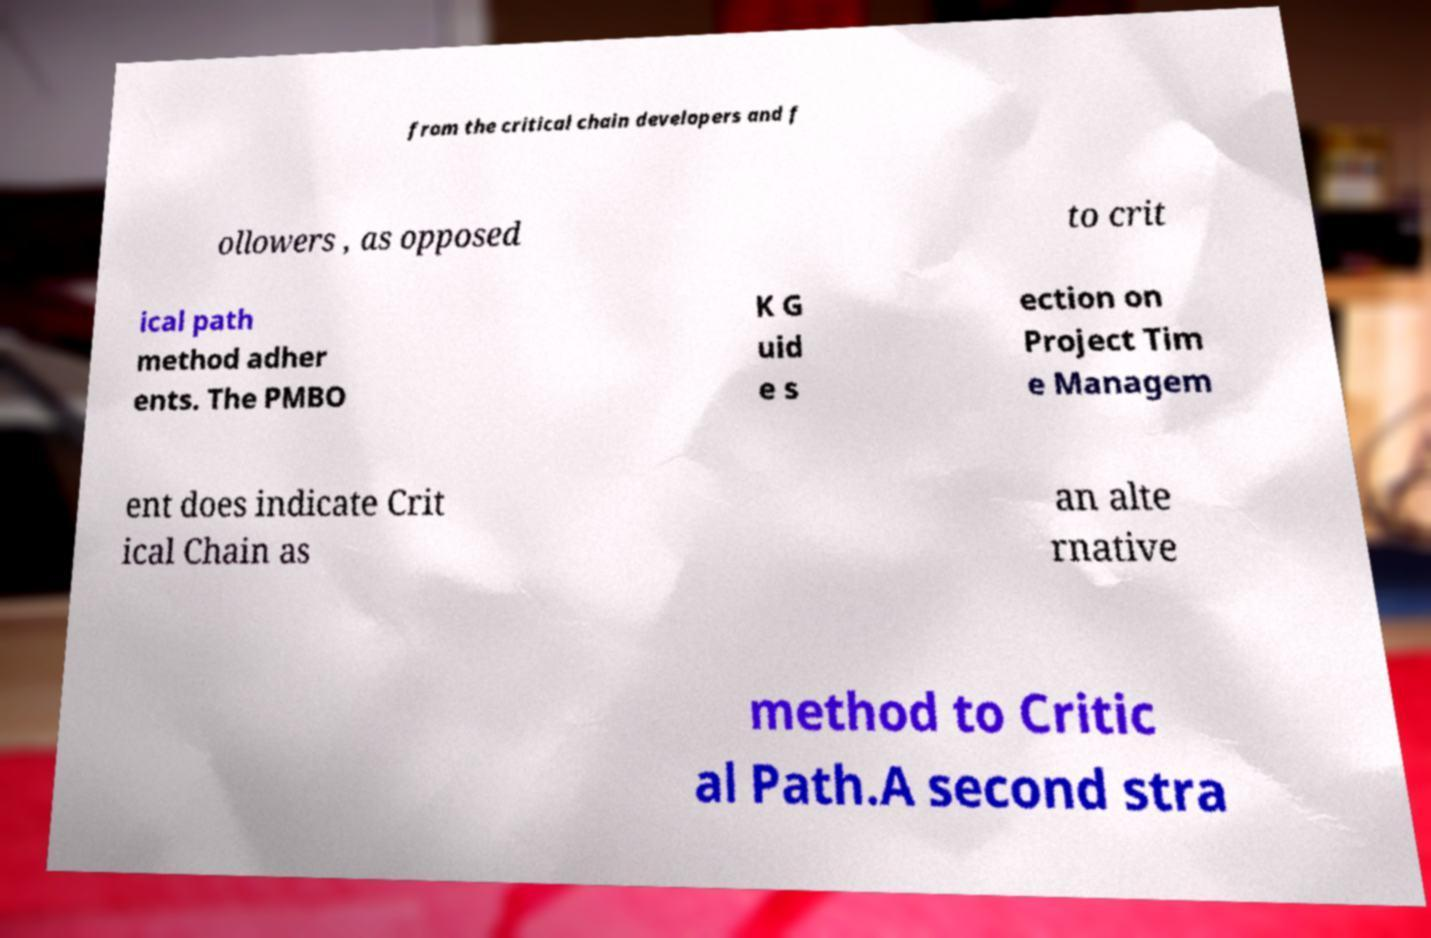There's text embedded in this image that I need extracted. Can you transcribe it verbatim? from the critical chain developers and f ollowers , as opposed to crit ical path method adher ents. The PMBO K G uid e s ection on Project Tim e Managem ent does indicate Crit ical Chain as an alte rnative method to Critic al Path.A second stra 